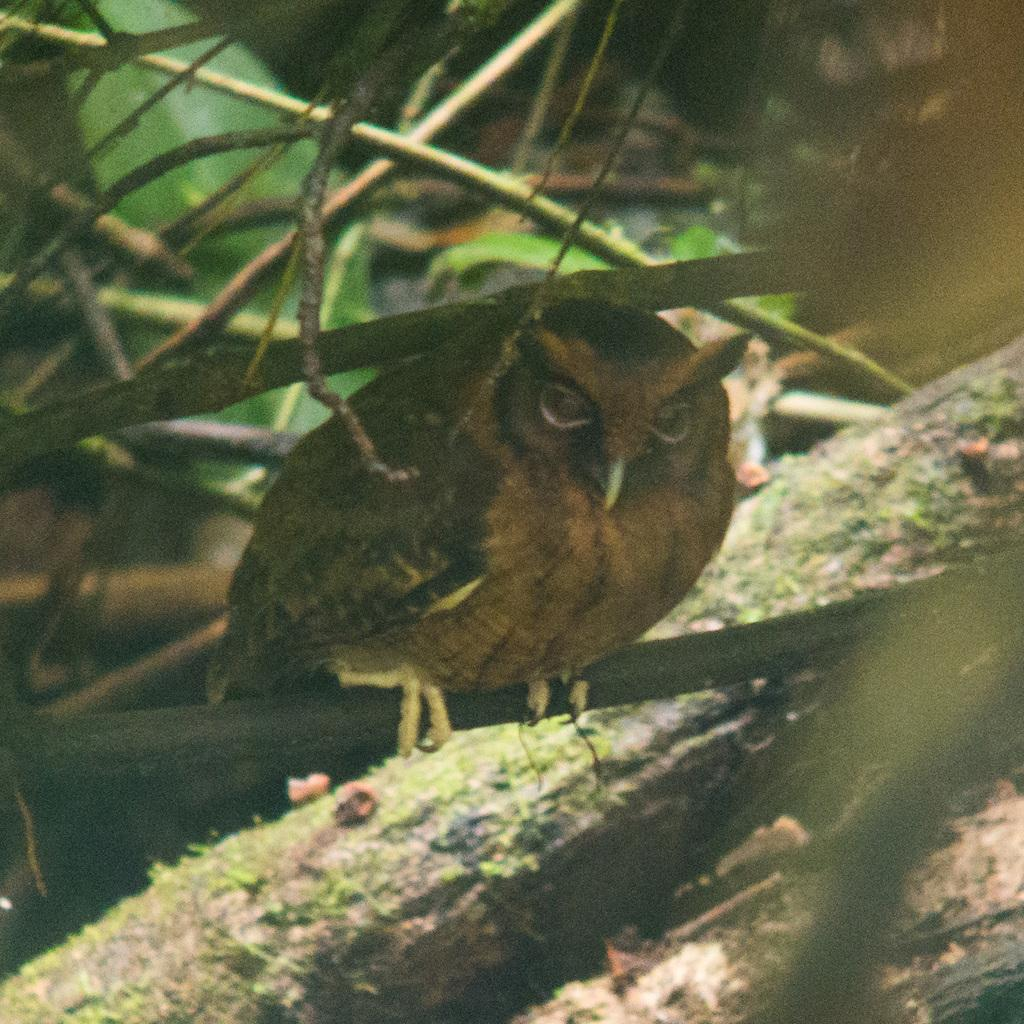What animal is the main subject of the image? There is an owl in the image. Where is the owl located in the image? The owl is on a branch of a tree. What can be seen in the background of the image? There are trees visible in the background of the image. What language is the owl speaking in the image? Owls do not speak human languages, so there is no language spoken by the owl in the image. 